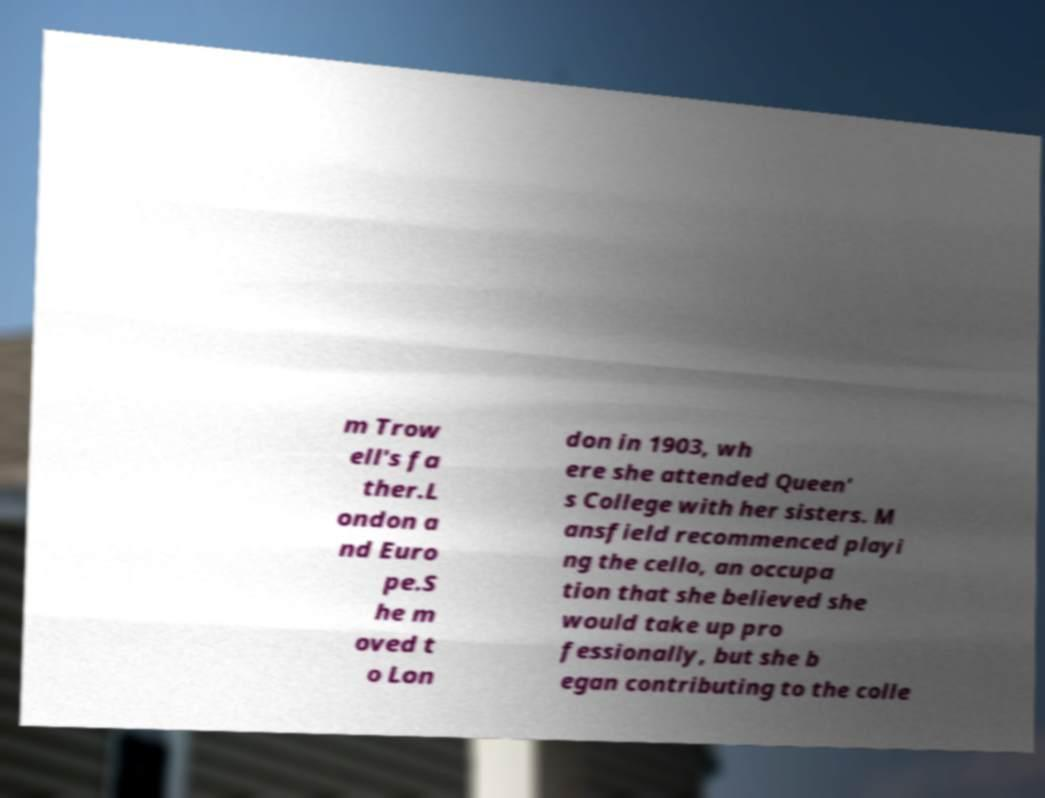Can you read and provide the text displayed in the image?This photo seems to have some interesting text. Can you extract and type it out for me? m Trow ell's fa ther.L ondon a nd Euro pe.S he m oved t o Lon don in 1903, wh ere she attended Queen' s College with her sisters. M ansfield recommenced playi ng the cello, an occupa tion that she believed she would take up pro fessionally, but she b egan contributing to the colle 